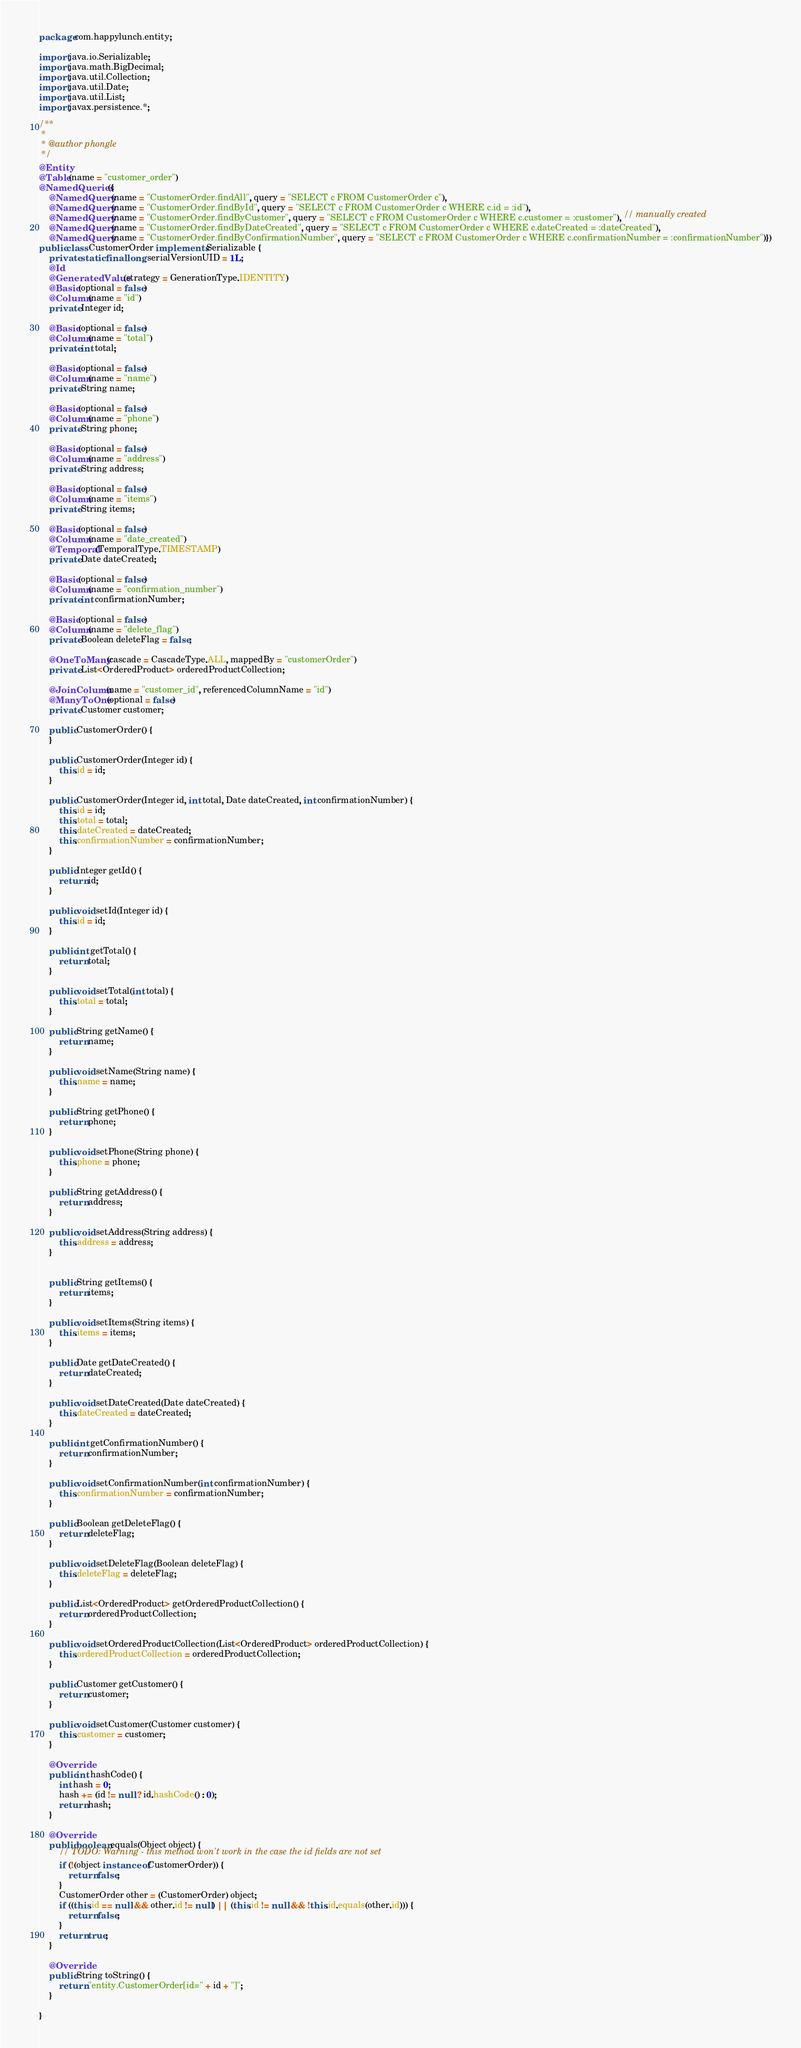<code> <loc_0><loc_0><loc_500><loc_500><_Java_>package com.happylunch.entity;

import java.io.Serializable;
import java.math.BigDecimal;
import java.util.Collection;
import java.util.Date;
import java.util.List;
import javax.persistence.*;

/**
 *
 * @author phongle
 */
@Entity
@Table(name = "customer_order")
@NamedQueries({
    @NamedQuery(name = "CustomerOrder.findAll", query = "SELECT c FROM CustomerOrder c"),
    @NamedQuery(name = "CustomerOrder.findById", query = "SELECT c FROM CustomerOrder c WHERE c.id = :id"),
    @NamedQuery(name = "CustomerOrder.findByCustomer", query = "SELECT c FROM CustomerOrder c WHERE c.customer = :customer"), // manually created
    @NamedQuery(name = "CustomerOrder.findByDateCreated", query = "SELECT c FROM CustomerOrder c WHERE c.dateCreated = :dateCreated"),
    @NamedQuery(name = "CustomerOrder.findByConfirmationNumber", query = "SELECT c FROM CustomerOrder c WHERE c.confirmationNumber = :confirmationNumber")})
public class CustomerOrder implements Serializable {
    private static final long serialVersionUID = 1L;
    @Id
    @GeneratedValue(strategy = GenerationType.IDENTITY)
    @Basic(optional = false)
    @Column(name = "id")
    private Integer id;

    @Basic(optional = false)
    @Column(name = "total")
    private int total;

    @Basic(optional = false)
    @Column(name = "name")
    private String name;

    @Basic(optional = false)
    @Column(name = "phone")
    private String phone;

    @Basic(optional = false)
    @Column(name = "address")
    private String address;

    @Basic(optional = false)
    @Column(name = "items")
    private String items;

    @Basic(optional = false)
    @Column(name = "date_created")
    @Temporal(TemporalType.TIMESTAMP)
    private Date dateCreated;

    @Basic(optional = false)
    @Column(name = "confirmation_number")
    private int confirmationNumber;

    @Basic(optional = false)
    @Column(name = "delete_flag")
    private Boolean deleteFlag = false;

    @OneToMany(cascade = CascadeType.ALL, mappedBy = "customerOrder")
    private List<OrderedProduct> orderedProductCollection;

    @JoinColumn(name = "customer_id", referencedColumnName = "id")
    @ManyToOne(optional = false)
    private Customer customer;

    public CustomerOrder() {
    }

    public CustomerOrder(Integer id) {
        this.id = id;
    }

    public CustomerOrder(Integer id, int total, Date dateCreated, int confirmationNumber) {
        this.id = id;
        this.total = total;
        this.dateCreated = dateCreated;
        this.confirmationNumber = confirmationNumber;
    }

    public Integer getId() {
        return id;
    }

    public void setId(Integer id) {
        this.id = id;
    }

    public int getTotal() {
        return total;
    }

    public void setTotal(int total) {
        this.total = total;
    }

    public String getName() {
        return name;
    }

    public void setName(String name) {
        this.name = name;
    }

    public String getPhone() {
        return phone;
    }

    public void setPhone(String phone) {
        this.phone = phone;
    }

    public String getAddress() {
        return address;
    }

    public void setAddress(String address) {
        this.address = address;
    }


    public String getItems() {
        return items;
    }

    public void setItems(String items) {
        this.items = items;
    }

    public Date getDateCreated() {
        return dateCreated;
    }

    public void setDateCreated(Date dateCreated) {
        this.dateCreated = dateCreated;
    }

    public int getConfirmationNumber() {
        return confirmationNumber;
    }

    public void setConfirmationNumber(int confirmationNumber) {
        this.confirmationNumber = confirmationNumber;
    }

    public Boolean getDeleteFlag() {
        return deleteFlag;
    }

    public void setDeleteFlag(Boolean deleteFlag) {
        this.deleteFlag = deleteFlag;
    }

    public List<OrderedProduct> getOrderedProductCollection() {
        return orderedProductCollection;
    }

    public void setOrderedProductCollection(List<OrderedProduct> orderedProductCollection) {
        this.orderedProductCollection = orderedProductCollection;
    }

    public Customer getCustomer() {
        return customer;
    }

    public void setCustomer(Customer customer) {
        this.customer = customer;
    }

    @Override
    public int hashCode() {
        int hash = 0;
        hash += (id != null ? id.hashCode() : 0);
        return hash;
    }

    @Override
    public boolean equals(Object object) {
        // TODO: Warning - this method won't work in the case the id fields are not set
        if (!(object instanceof CustomerOrder)) {
            return false;
        }
        CustomerOrder other = (CustomerOrder) object;
        if ((this.id == null && other.id != null) || (this.id != null && !this.id.equals(other.id))) {
            return false;
        }
        return true;
    }

    @Override
    public String toString() {
        return "entity.CustomerOrder[id=" + id + "]";
    }

}</code> 